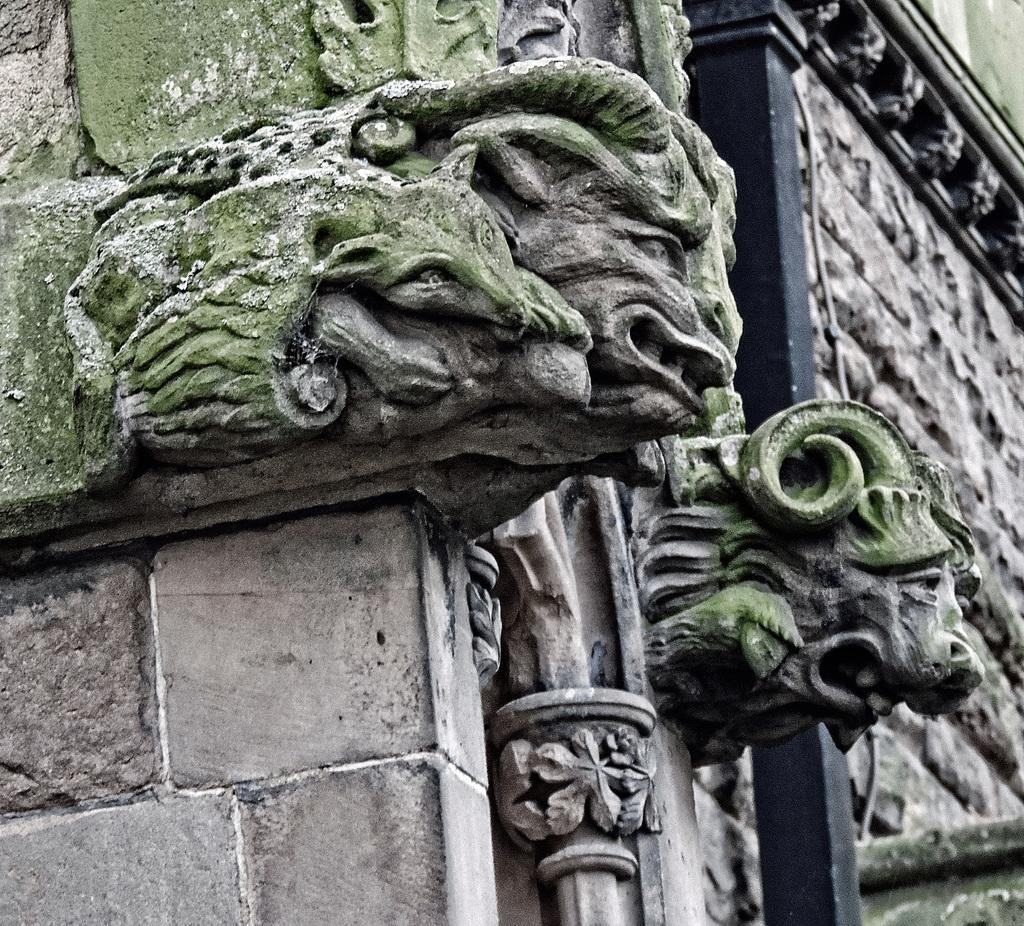What is depicted on the wall in the image? There are sculptures on the wall in the image. What statement is being made by the fish in the image? There are no fish present in the image; it features sculptures on the wall. 